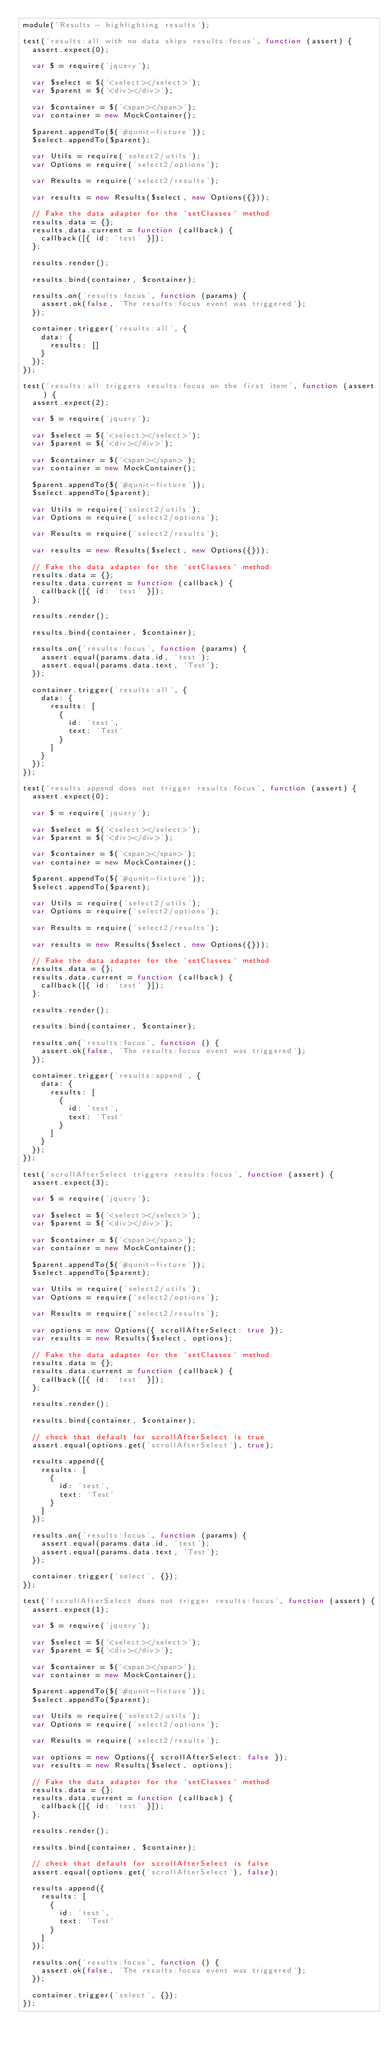Convert code to text. <code><loc_0><loc_0><loc_500><loc_500><_JavaScript_>module('Results - highlighting results');

test('results:all with no data skips results:focus', function (assert) {
  assert.expect(0);

  var $ = require('jquery');

  var $select = $('<select></select>');
  var $parent = $('<div></div>');

  var $container = $('<span></span>');
  var container = new MockContainer();

  $parent.appendTo($('#qunit-fixture'));
  $select.appendTo($parent);

  var Utils = require('select2/utils');
  var Options = require('select2/options');

  var Results = require('select2/results');

  var results = new Results($select, new Options({}));

  // Fake the data adapter for the `setClasses` method
  results.data = {};
  results.data.current = function (callback) {
    callback([{ id: 'test' }]);
  };

  results.render();

  results.bind(container, $container);

  results.on('results:focus', function (params) {
    assert.ok(false, 'The results:focus event was triggered');
  });

  container.trigger('results:all', {
    data: {
      results: []
    }
  });
});

test('results:all triggers results:focus on the first item', function (assert) {
  assert.expect(2);

  var $ = require('jquery');

  var $select = $('<select></select>');
  var $parent = $('<div></div>');

  var $container = $('<span></span>');
  var container = new MockContainer();

  $parent.appendTo($('#qunit-fixture'));
  $select.appendTo($parent);

  var Utils = require('select2/utils');
  var Options = require('select2/options');

  var Results = require('select2/results');

  var results = new Results($select, new Options({}));

  // Fake the data adapter for the `setClasses` method
  results.data = {};
  results.data.current = function (callback) {
    callback([{ id: 'test' }]);
  };

  results.render();

  results.bind(container, $container);

  results.on('results:focus', function (params) {
    assert.equal(params.data.id, 'test');
    assert.equal(params.data.text, 'Test');
  });

  container.trigger('results:all', {
    data: {
      results: [
        {
          id: 'test',
          text: 'Test'
        }
      ]
    }
  });
});

test('results:append does not trigger results:focus', function (assert) {
  assert.expect(0);

  var $ = require('jquery');

  var $select = $('<select></select>');
  var $parent = $('<div></div>');

  var $container = $('<span></span>');
  var container = new MockContainer();

  $parent.appendTo($('#qunit-fixture'));
  $select.appendTo($parent);

  var Utils = require('select2/utils');
  var Options = require('select2/options');

  var Results = require('select2/results');

  var results = new Results($select, new Options({}));

  // Fake the data adapter for the `setClasses` method
  results.data = {};
  results.data.current = function (callback) {
    callback([{ id: 'test' }]);
  };

  results.render();

  results.bind(container, $container);

  results.on('results:focus', function () {
    assert.ok(false, 'The results:focus event was triggered');
  });

  container.trigger('results:append', {
    data: {
      results: [
        {
          id: 'test',
          text: 'Test'
        }
      ]
    }
  });
});

test('scrollAfterSelect triggers results:focus', function (assert) {
  assert.expect(3);

  var $ = require('jquery');

  var $select = $('<select></select>');
  var $parent = $('<div></div>');

  var $container = $('<span></span>');
  var container = new MockContainer();

  $parent.appendTo($('#qunit-fixture'));
  $select.appendTo($parent);

  var Utils = require('select2/utils');
  var Options = require('select2/options');

  var Results = require('select2/results');

  var options = new Options({ scrollAfterSelect: true });
  var results = new Results($select, options);

  // Fake the data adapter for the `setClasses` method
  results.data = {};
  results.data.current = function (callback) {
    callback([{ id: 'test' }]);
  };

  results.render();

  results.bind(container, $container);

  // check that default for scrollAfterSelect is true
  assert.equal(options.get('scrollAfterSelect'), true);

  results.append({
    results: [
      {
        id: 'test',
        text: 'Test'
      }
    ]
  });

  results.on('results:focus', function (params) {
    assert.equal(params.data.id, 'test');
    assert.equal(params.data.text, 'Test');
  });

  container.trigger('select', {});
});

test('!scrollAfterSelect does not trigger results:focus', function (assert) {
  assert.expect(1);

  var $ = require('jquery');

  var $select = $('<select></select>');
  var $parent = $('<div></div>');

  var $container = $('<span></span>');
  var container = new MockContainer();

  $parent.appendTo($('#qunit-fixture'));
  $select.appendTo($parent);

  var Utils = require('select2/utils');
  var Options = require('select2/options');

  var Results = require('select2/results');

  var options = new Options({ scrollAfterSelect: false });
  var results = new Results($select, options);

  // Fake the data adapter for the `setClasses` method
  results.data = {};
  results.data.current = function (callback) {
    callback([{ id: 'test' }]);
  };

  results.render();

  results.bind(container, $container);

  // check that default for scrollAfterSelect is false
  assert.equal(options.get('scrollAfterSelect'), false);

  results.append({
    results: [
      {
        id: 'test',
        text: 'Test'
      }
    ]
  });

  results.on('results:focus', function () {
    assert.ok(false, 'The results:focus event was triggered');
  });

  container.trigger('select', {});
});
</code> 